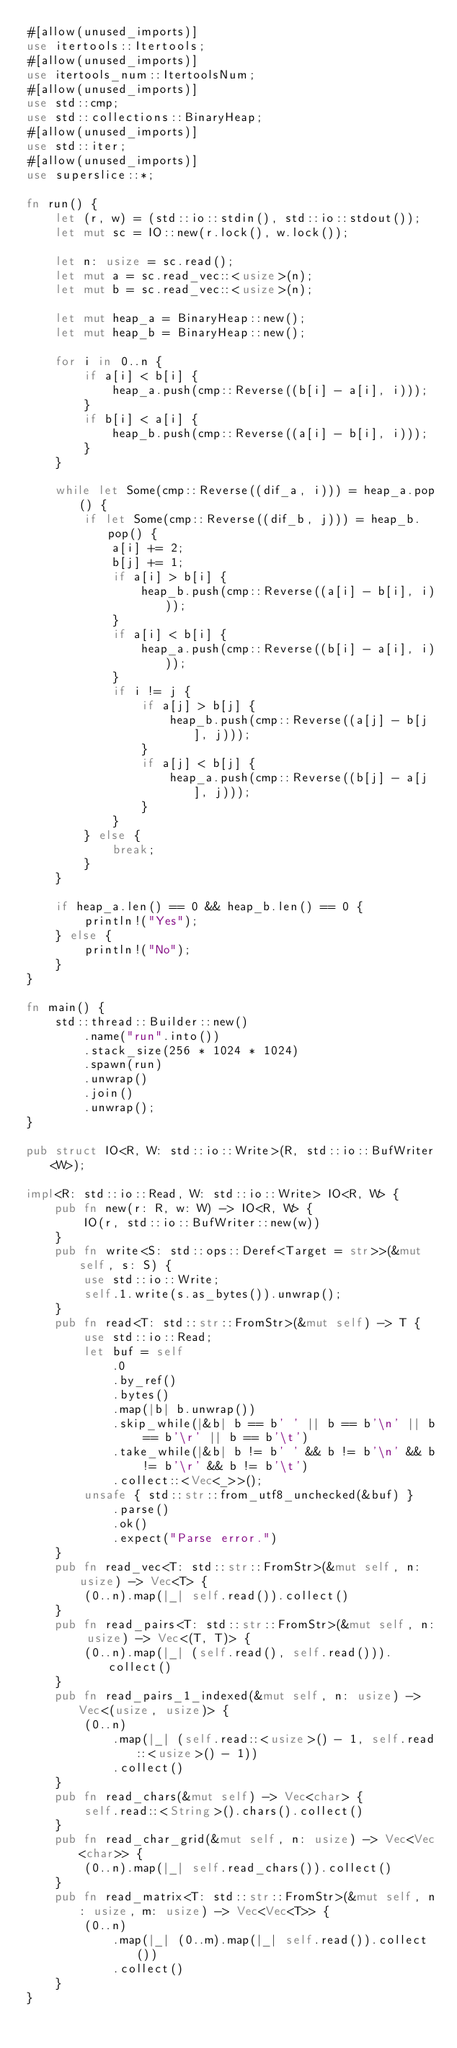Convert code to text. <code><loc_0><loc_0><loc_500><loc_500><_Rust_>#[allow(unused_imports)]
use itertools::Itertools;
#[allow(unused_imports)]
use itertools_num::ItertoolsNum;
#[allow(unused_imports)]
use std::cmp;
use std::collections::BinaryHeap;
#[allow(unused_imports)]
use std::iter;
#[allow(unused_imports)]
use superslice::*;

fn run() {
    let (r, w) = (std::io::stdin(), std::io::stdout());
    let mut sc = IO::new(r.lock(), w.lock());

    let n: usize = sc.read();
    let mut a = sc.read_vec::<usize>(n);
    let mut b = sc.read_vec::<usize>(n);

    let mut heap_a = BinaryHeap::new();
    let mut heap_b = BinaryHeap::new();

    for i in 0..n {
        if a[i] < b[i] {
            heap_a.push(cmp::Reverse((b[i] - a[i], i)));
        }
        if b[i] < a[i] {
            heap_b.push(cmp::Reverse((a[i] - b[i], i)));
        }
    }

    while let Some(cmp::Reverse((dif_a, i))) = heap_a.pop() {
        if let Some(cmp::Reverse((dif_b, j))) = heap_b.pop() {
            a[i] += 2;
            b[j] += 1;
            if a[i] > b[i] {
                heap_b.push(cmp::Reverse((a[i] - b[i], i)));
            }
            if a[i] < b[i] {
                heap_a.push(cmp::Reverse((b[i] - a[i], i)));
            }
            if i != j {
                if a[j] > b[j] {
                    heap_b.push(cmp::Reverse((a[j] - b[j], j)));
                }
                if a[j] < b[j] {
                    heap_a.push(cmp::Reverse((b[j] - a[j], j)));
                }
            }
        } else {
            break;
        }
    }

    if heap_a.len() == 0 && heap_b.len() == 0 {
        println!("Yes");
    } else {
        println!("No");
    }
}

fn main() {
    std::thread::Builder::new()
        .name("run".into())
        .stack_size(256 * 1024 * 1024)
        .spawn(run)
        .unwrap()
        .join()
        .unwrap();
}

pub struct IO<R, W: std::io::Write>(R, std::io::BufWriter<W>);

impl<R: std::io::Read, W: std::io::Write> IO<R, W> {
    pub fn new(r: R, w: W) -> IO<R, W> {
        IO(r, std::io::BufWriter::new(w))
    }
    pub fn write<S: std::ops::Deref<Target = str>>(&mut self, s: S) {
        use std::io::Write;
        self.1.write(s.as_bytes()).unwrap();
    }
    pub fn read<T: std::str::FromStr>(&mut self) -> T {
        use std::io::Read;
        let buf = self
            .0
            .by_ref()
            .bytes()
            .map(|b| b.unwrap())
            .skip_while(|&b| b == b' ' || b == b'\n' || b == b'\r' || b == b'\t')
            .take_while(|&b| b != b' ' && b != b'\n' && b != b'\r' && b != b'\t')
            .collect::<Vec<_>>();
        unsafe { std::str::from_utf8_unchecked(&buf) }
            .parse()
            .ok()
            .expect("Parse error.")
    }
    pub fn read_vec<T: std::str::FromStr>(&mut self, n: usize) -> Vec<T> {
        (0..n).map(|_| self.read()).collect()
    }
    pub fn read_pairs<T: std::str::FromStr>(&mut self, n: usize) -> Vec<(T, T)> {
        (0..n).map(|_| (self.read(), self.read())).collect()
    }
    pub fn read_pairs_1_indexed(&mut self, n: usize) -> Vec<(usize, usize)> {
        (0..n)
            .map(|_| (self.read::<usize>() - 1, self.read::<usize>() - 1))
            .collect()
    }
    pub fn read_chars(&mut self) -> Vec<char> {
        self.read::<String>().chars().collect()
    }
    pub fn read_char_grid(&mut self, n: usize) -> Vec<Vec<char>> {
        (0..n).map(|_| self.read_chars()).collect()
    }
    pub fn read_matrix<T: std::str::FromStr>(&mut self, n: usize, m: usize) -> Vec<Vec<T>> {
        (0..n)
            .map(|_| (0..m).map(|_| self.read()).collect())
            .collect()
    }
}
</code> 